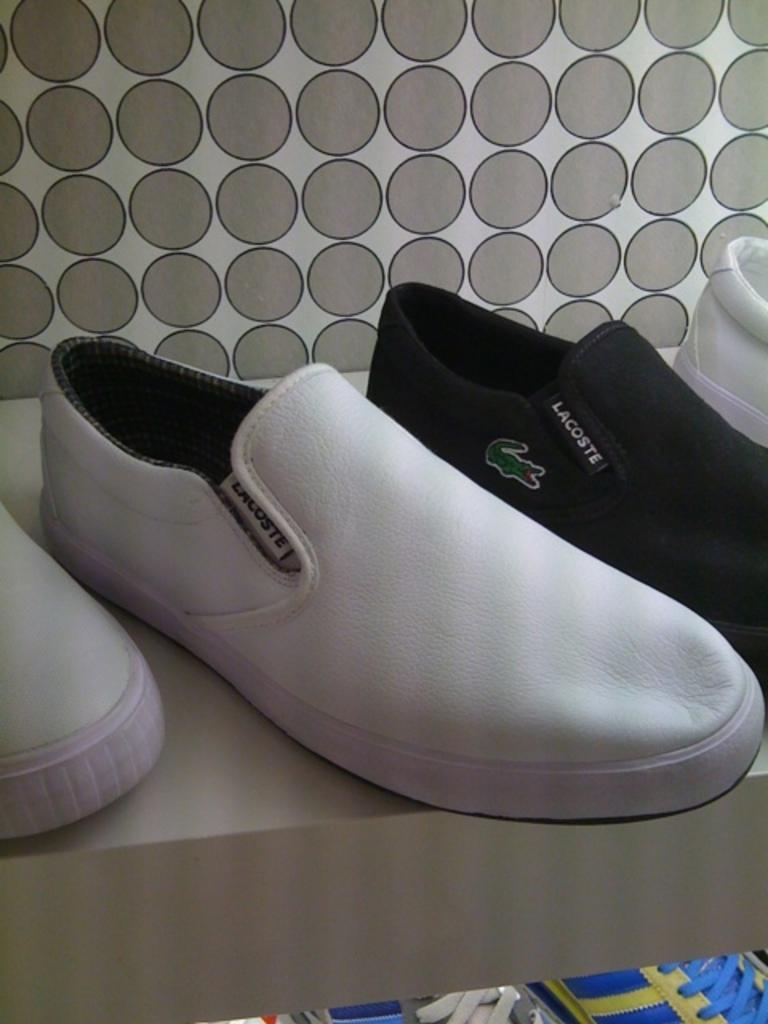How would you summarize this image in a sentence or two? In this picture we can see there are shoes on an object and in front of the shoes it looks like a box. Behind the shoes there is a wall. 